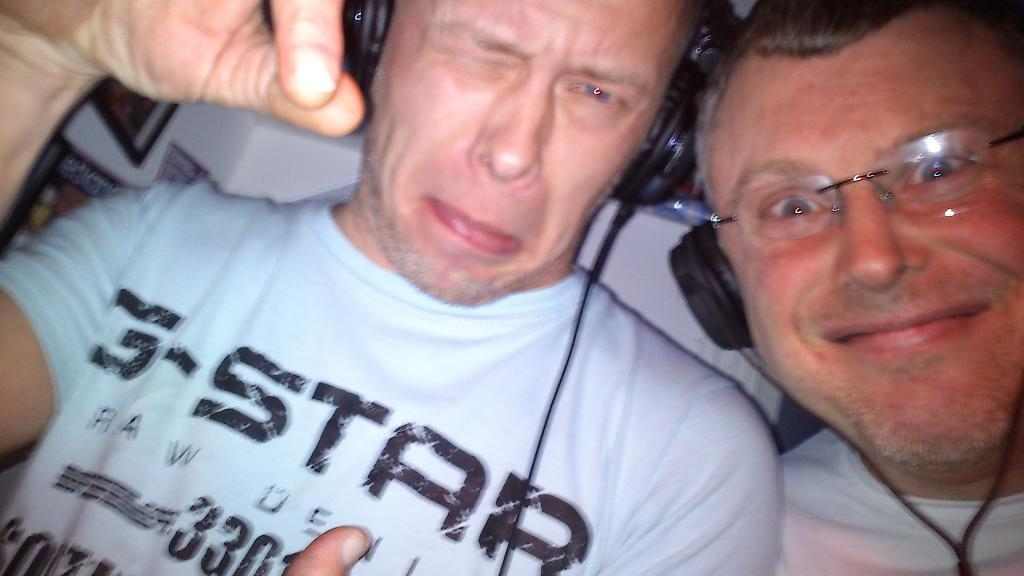How many people are in the image? There are two men in the image. What are the men wearing on their heads? Both men are wearing headsets. What type of trouble is the town facing in the image? There is no town or trouble depicted in the image; it features two men wearing headsets. 